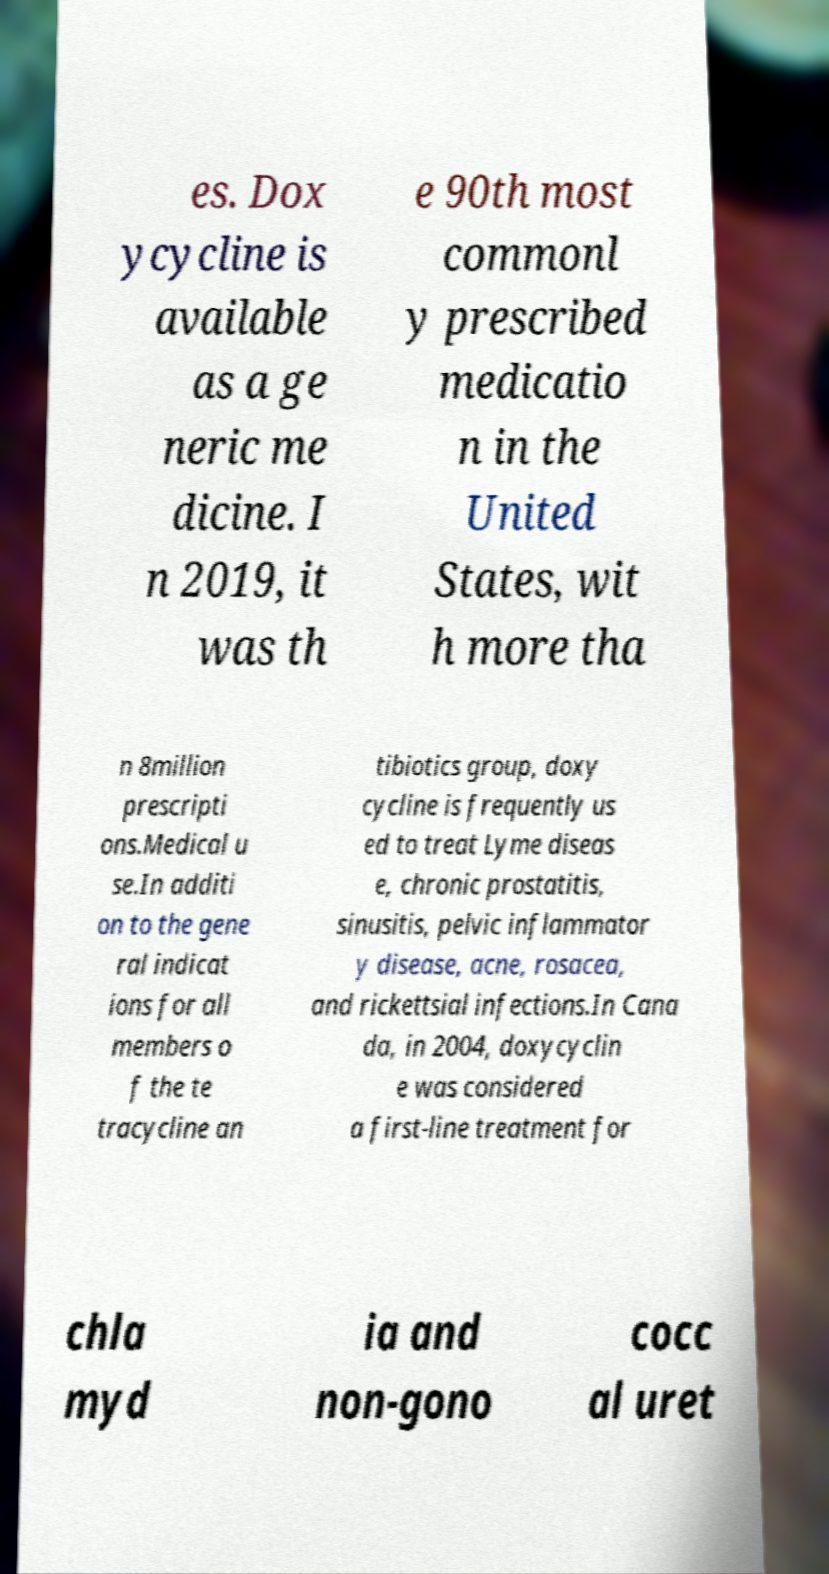For documentation purposes, I need the text within this image transcribed. Could you provide that? es. Dox ycycline is available as a ge neric me dicine. I n 2019, it was th e 90th most commonl y prescribed medicatio n in the United States, wit h more tha n 8million prescripti ons.Medical u se.In additi on to the gene ral indicat ions for all members o f the te tracycline an tibiotics group, doxy cycline is frequently us ed to treat Lyme diseas e, chronic prostatitis, sinusitis, pelvic inflammator y disease, acne, rosacea, and rickettsial infections.In Cana da, in 2004, doxycyclin e was considered a first-line treatment for chla myd ia and non-gono cocc al uret 